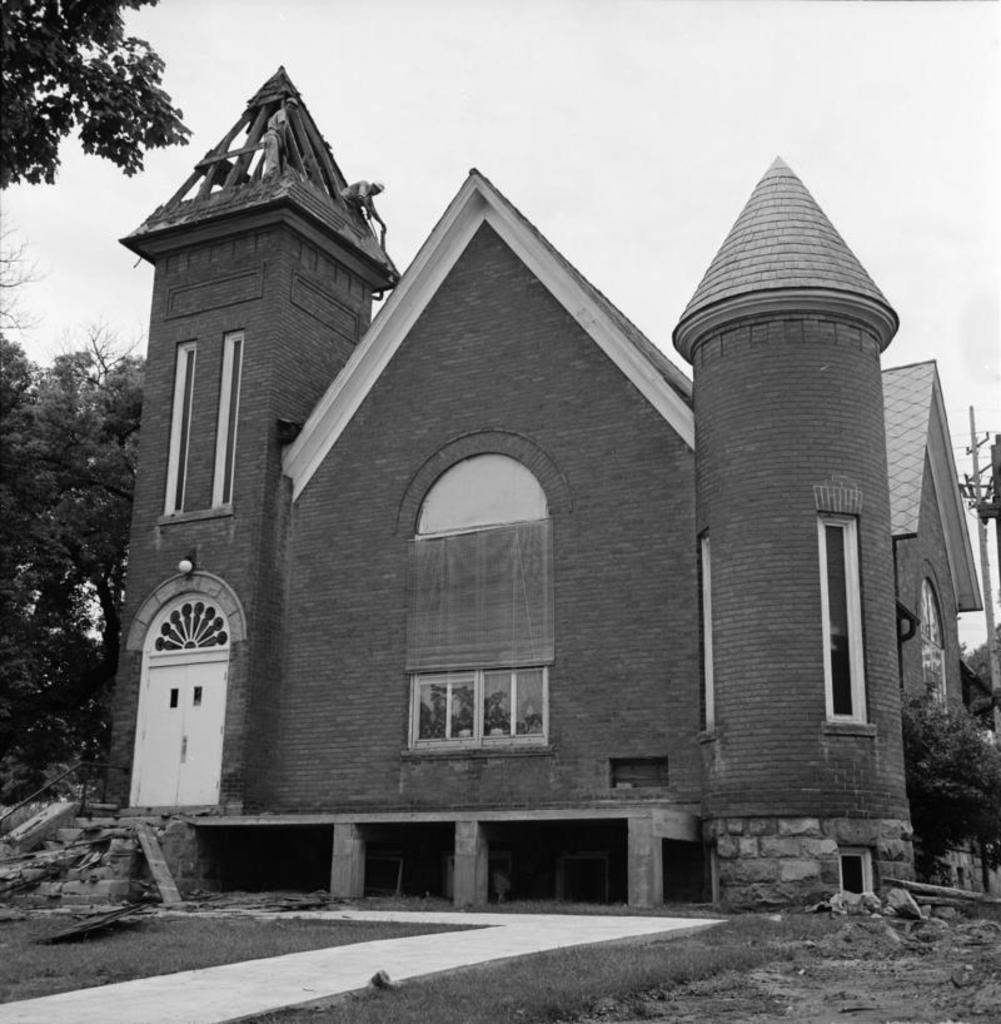What type of structure is present in the image? There is a house in the image. What can be seen on the left side of the image? There are trees on the left side of the image. What is visible at the top of the image? The sky is visible at the top of the image. What type of advertisement can be seen on the house in the image? There is no advertisement present on the house in the image. How are the jeans distributed in the image? There are no jeans present in the image. 